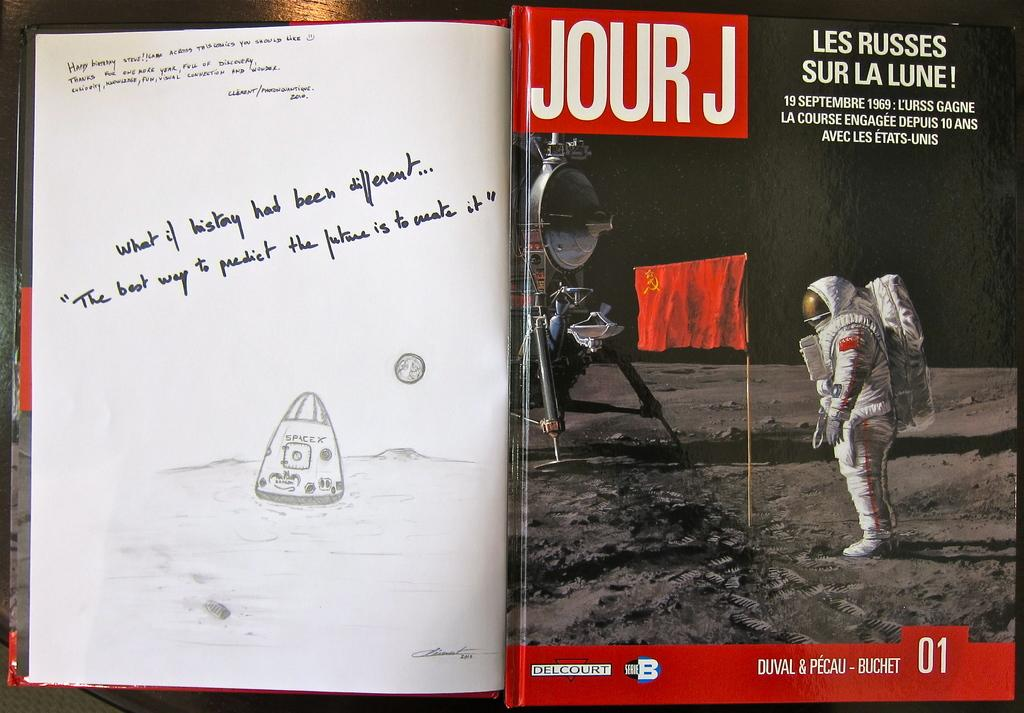<image>
Share a concise interpretation of the image provided. A book with a motivation note about creating our future and Jour J magazine on top of it. 